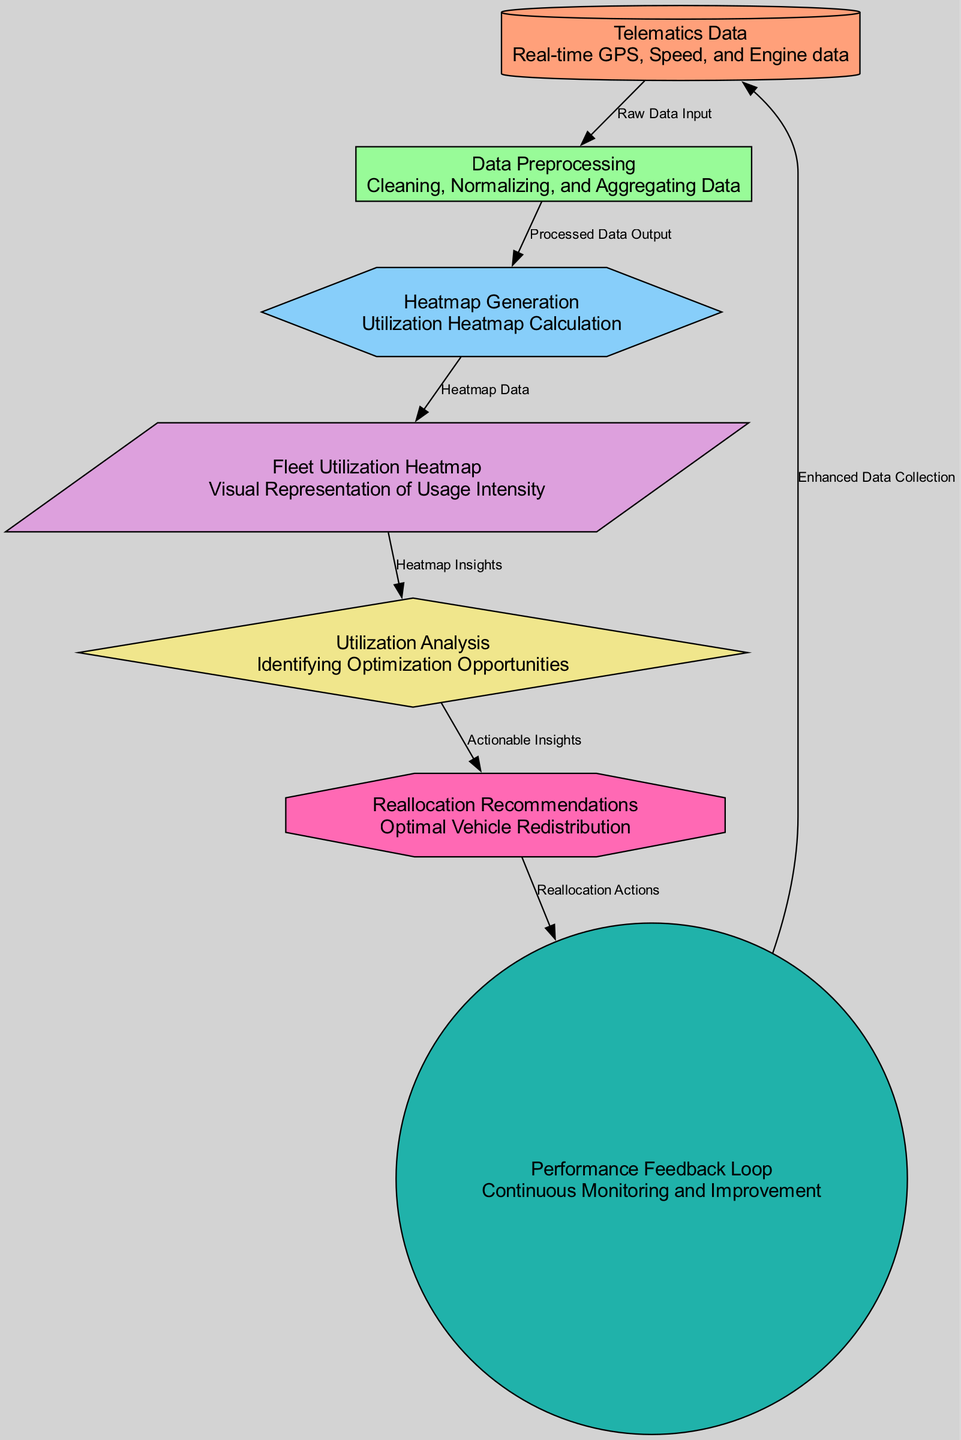What is the source of the data in this diagram? The diagram shows that the data source is "Telematics Data," which encompasses real-time GPS, Speed, and Engine data.
Answer: Telematics Data How many nodes are there in the diagram? By counting each unique node defined in the elements section of the diagram, there are seven nodes labeled from 1 to 7.
Answer: 7 Which process comes after Data Preprocessing? The diagram specifies that after the "Data Preprocessing" node, the next module is "Heatmap Generation."
Answer: Heatmap Generation What type of action is represented by node 6? The diagram categorizes node 6 as an "action" type, specifically labeled as "Reallocation Recommendations."
Answer: Reallocation Recommendations What connects Fleet Utilization Heatmap to Utilization Analysis? The connection between "Fleet Utilization Heatmap" and "Utilization Analysis" is established through the edge labeled as "Heatmap Insights."
Answer: Heatmap Insights How does the Performance Feedback Loop contribute to the data source? The "Performance Feedback Loop" sends information back to the "Telematics Data" for "Enhanced Data Collection," indicating a continuous improvement cycle.
Answer: Enhanced Data Collection What is the output of the Heatmap Generation module? The output from the "Heatmap Generation" module, according to the diagram, is the "Fleet Utilization Heatmap," providing a visual representation of usage intensity.
Answer: Fleet Utilization Heatmap What can be inferred after the Utilization Analysis step? After the "Utilization Analysis," the process leads to "Reallocation Recommendations," which focus on optimizing vehicle redistribution.
Answer: Reallocation Recommendations 